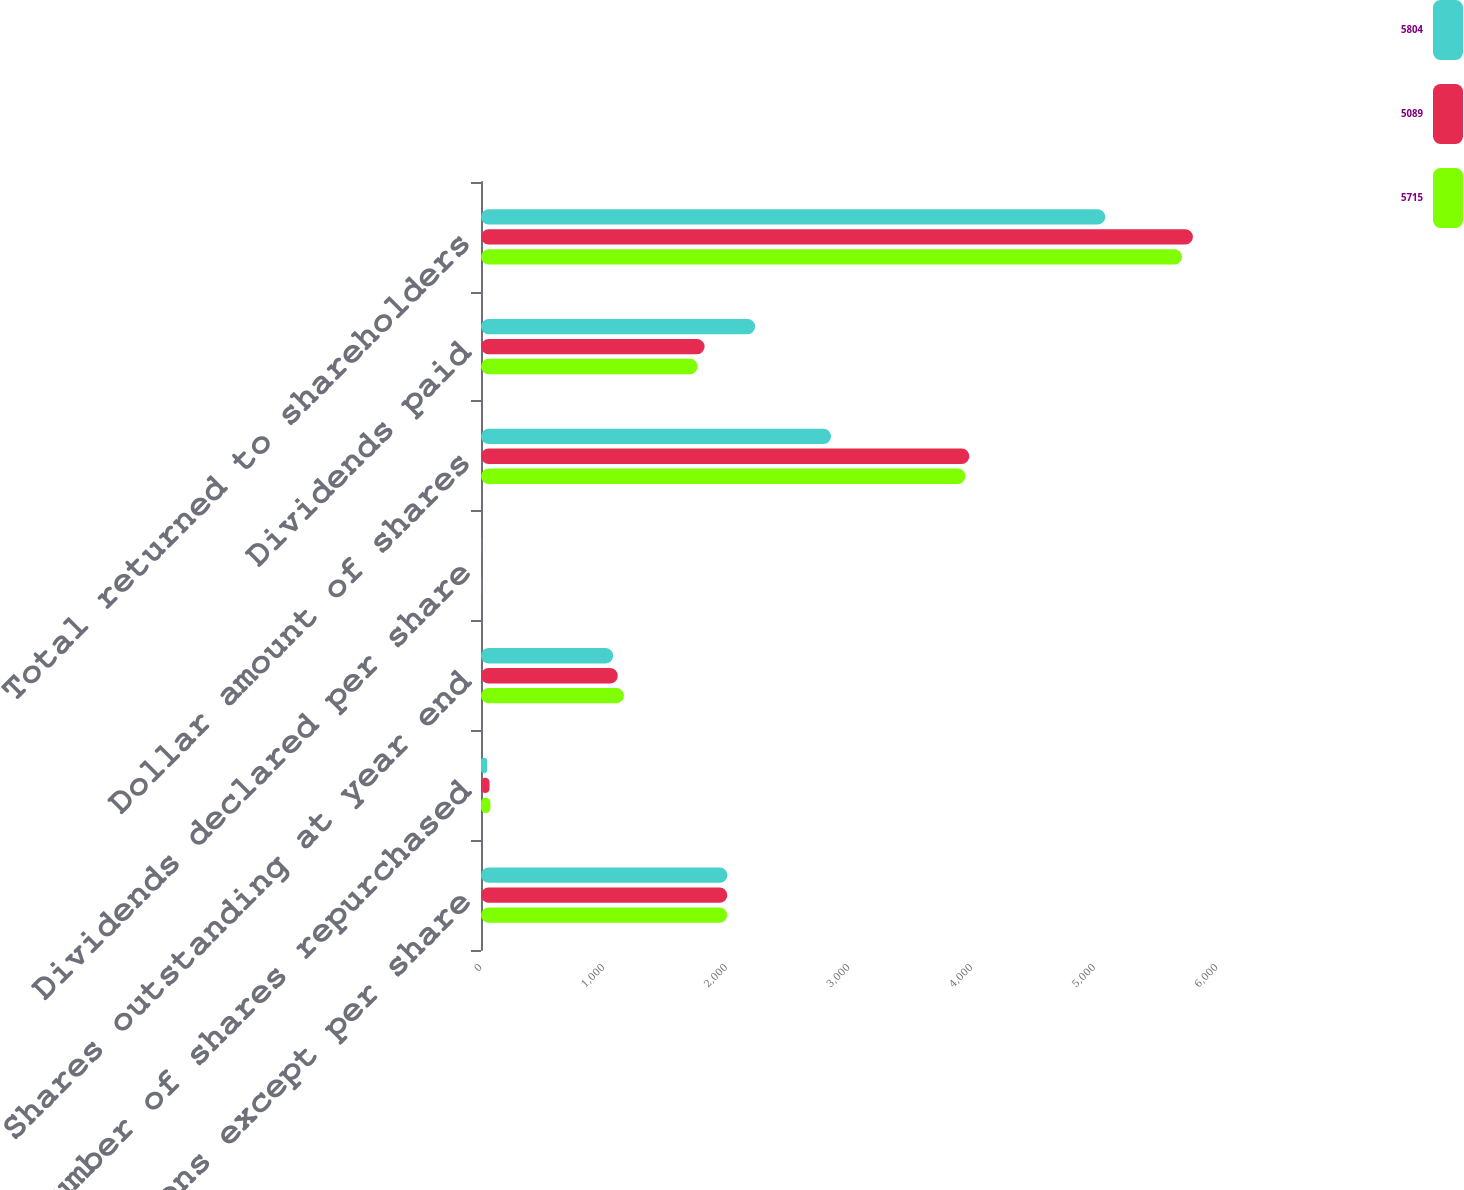Convert chart to OTSL. <chart><loc_0><loc_0><loc_500><loc_500><stacked_bar_chart><ecel><fcel>In millions except per share<fcel>Number of shares repurchased<fcel>Shares outstanding at year end<fcel>Dividends declared per share<fcel>Dollar amount of shares<fcel>Dividends paid<fcel>Total returned to shareholders<nl><fcel>5804<fcel>2009<fcel>50.3<fcel>1077<fcel>2.05<fcel>2854<fcel>2235<fcel>5089<nl><fcel>5089<fcel>2008<fcel>69.7<fcel>1115<fcel>1.62<fcel>3981<fcel>1823<fcel>5804<nl><fcel>5715<fcel>2007<fcel>77.1<fcel>1165<fcel>1.5<fcel>3949<fcel>1766<fcel>5715<nl></chart> 